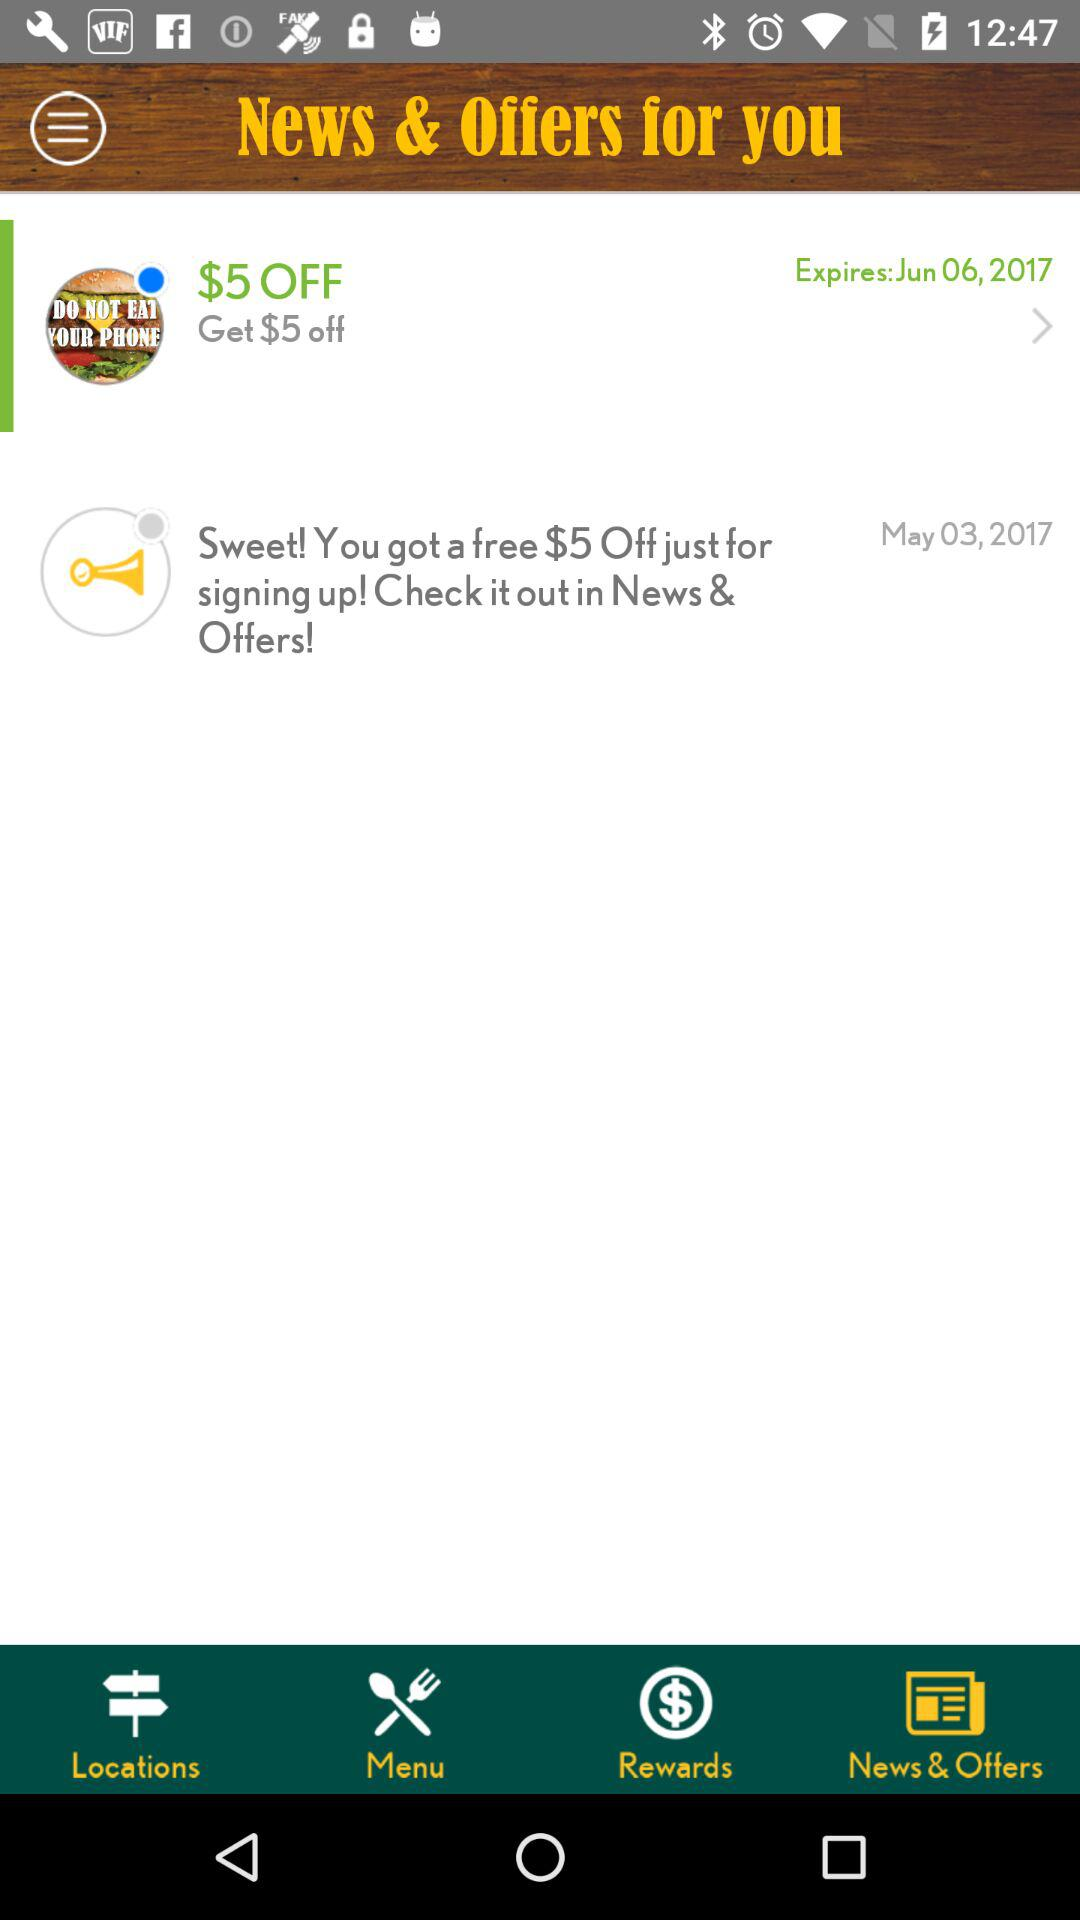What is the expiration date for getting $5 off? The expiration date is Jun 06, 2017. 